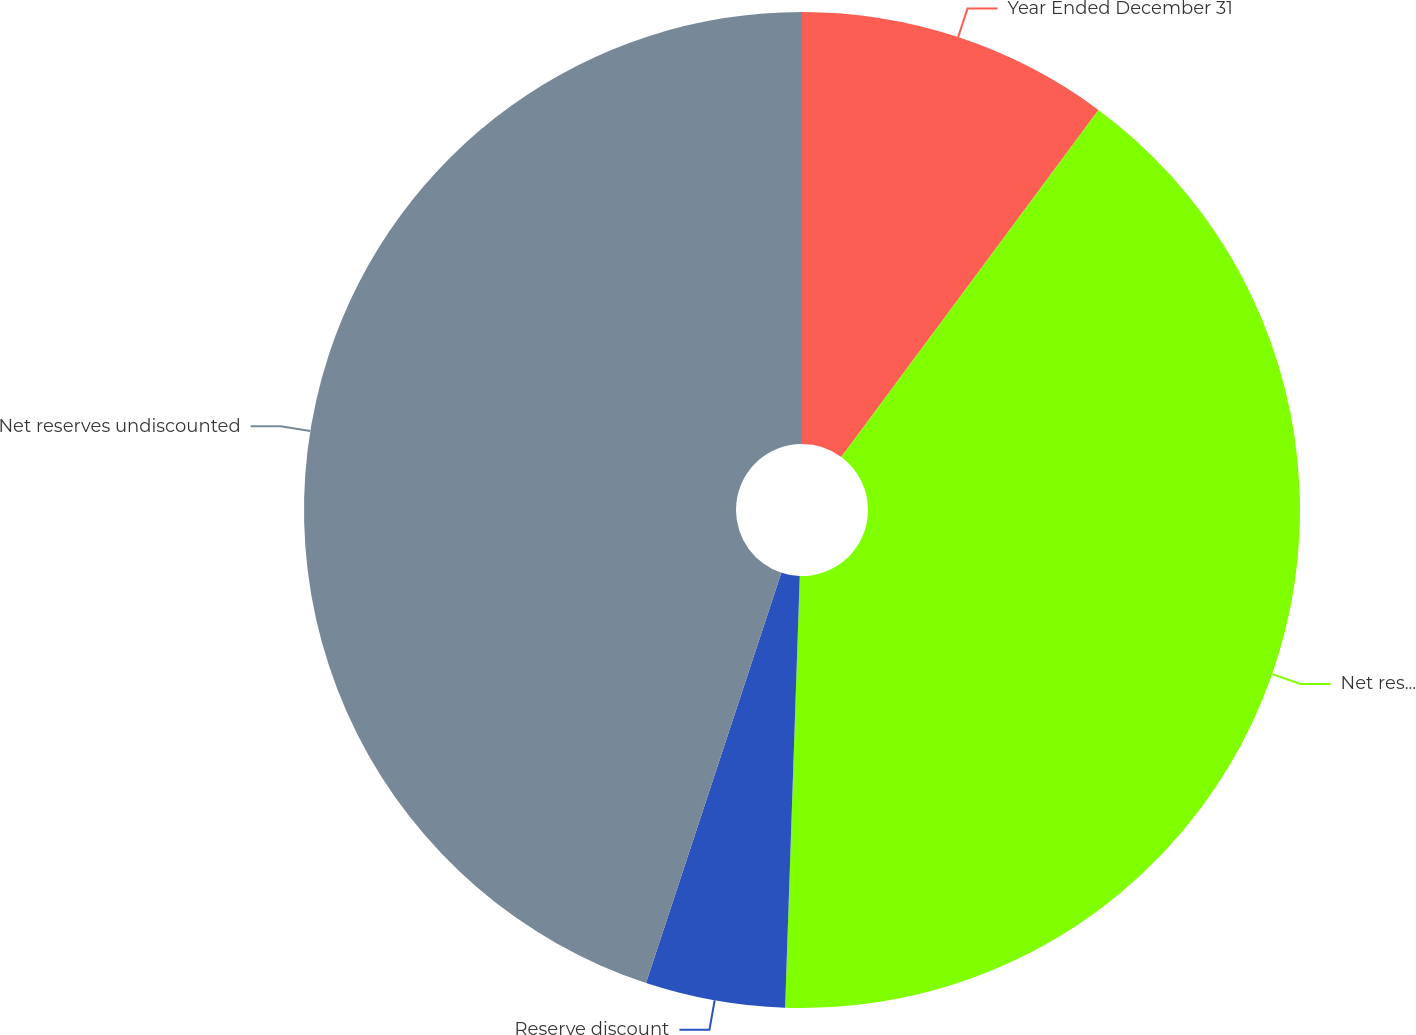Convert chart to OTSL. <chart><loc_0><loc_0><loc_500><loc_500><pie_chart><fcel>Year Ended December 31<fcel>Net reserves discounted<fcel>Reserve discount<fcel>Net reserves undiscounted<nl><fcel>10.15%<fcel>40.39%<fcel>4.53%<fcel>44.93%<nl></chart> 